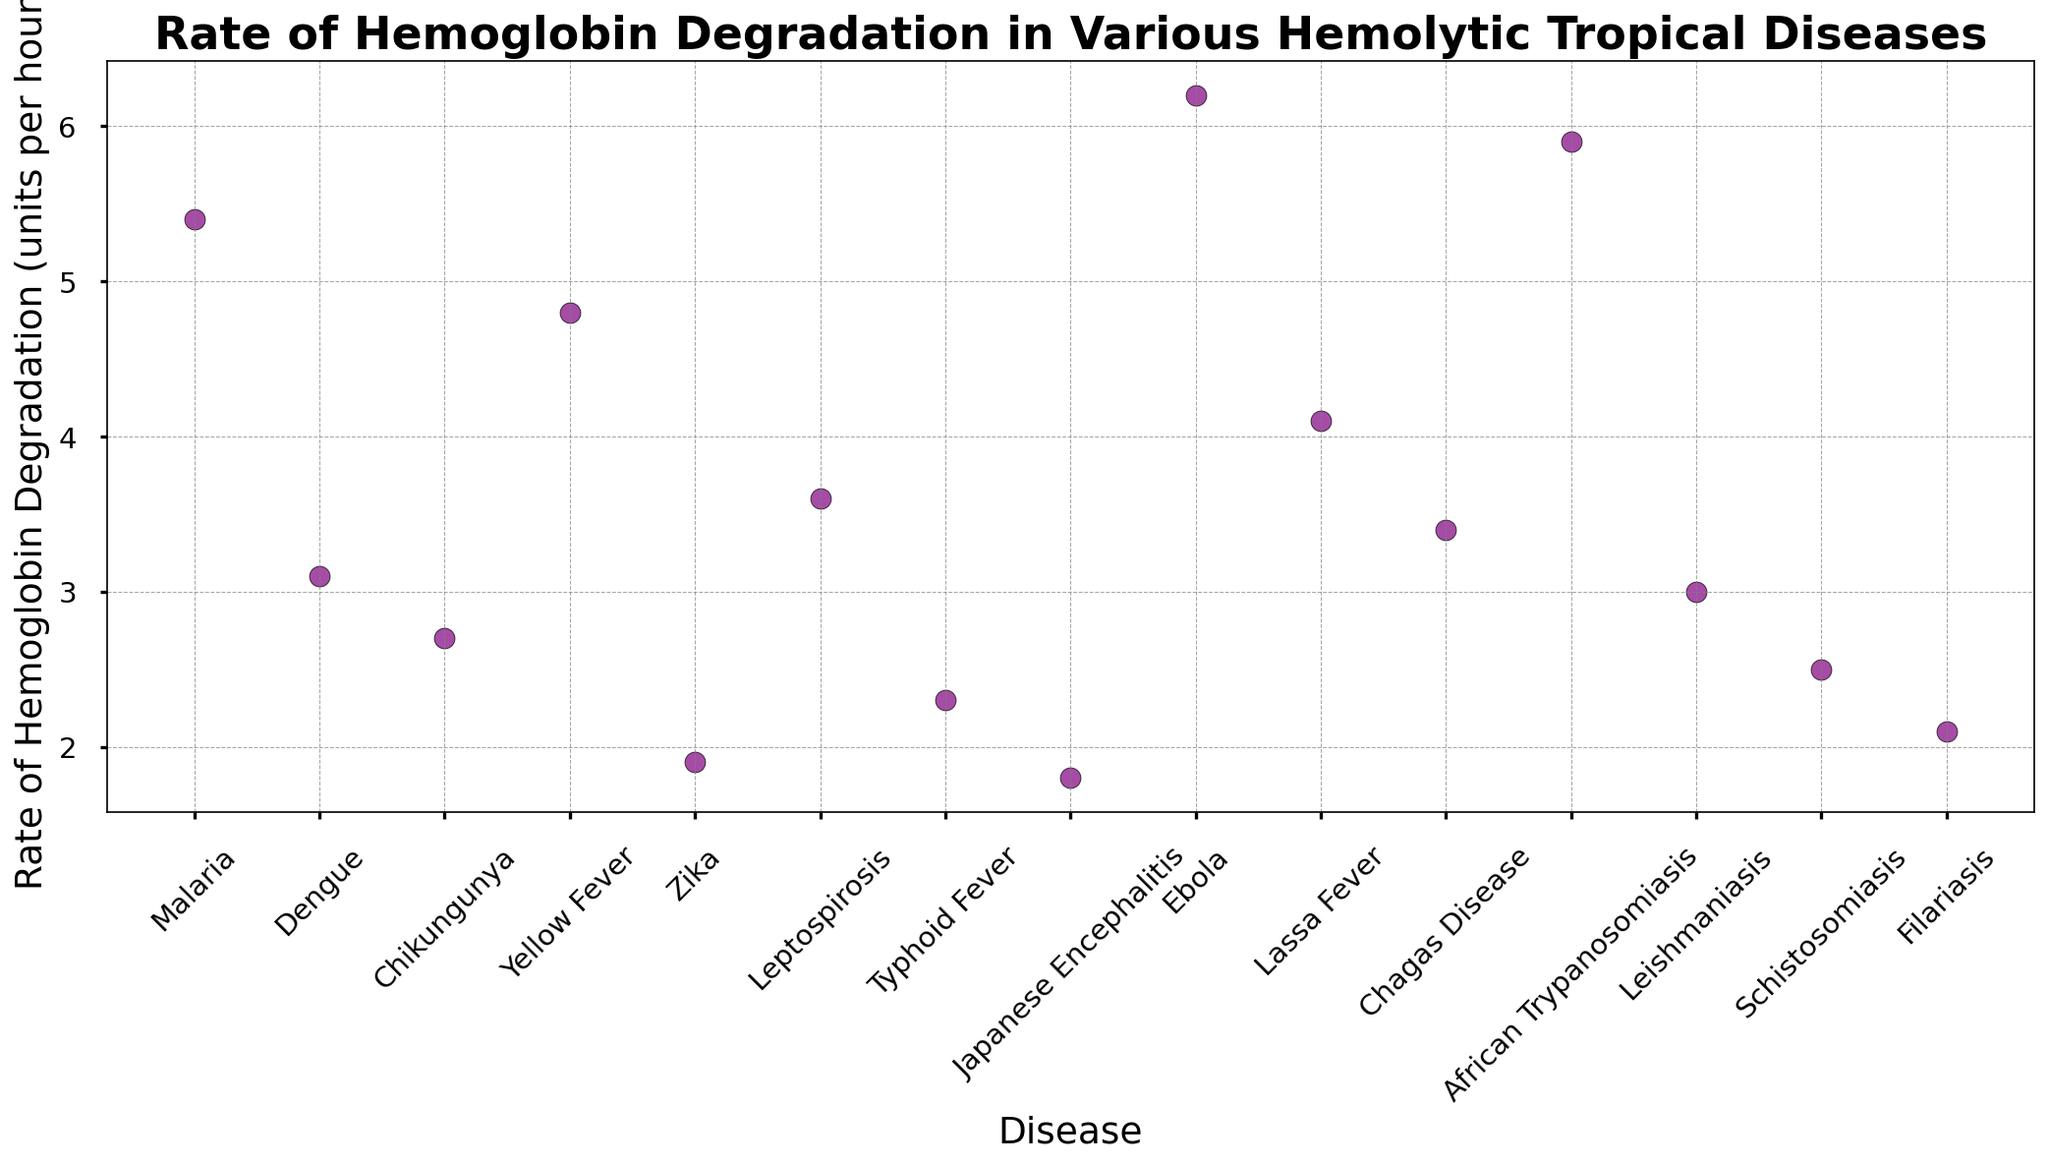Which disease has the highest rate of hemoglobin degradation? Look at the highest point in the scatter plot. The disease with the highest rate of hemoglobin degradation is Ebola at 6.2 units per hour.
Answer: Ebola What is the rate of hemoglobin degradation for Malaria? Identify the point corresponding to Malaria on the x-axis and check its y-value. The rate for Malaria is 5.4 units per hour.
Answer: 5.4 units per hour Which diseases have a rate of hemoglobin degradation higher than 4.5 units per hour? Locate all points with y-values greater than 4.5 units per hour. The diseases are Malaria, Yellow Fever, Ebola, and African Trypanosomiasis.
Answer: Malaria, Yellow Fever, Ebola, African Trypanosomiasis What is the difference in the rate of hemoglobin degradation between Ebola and Zika? Subtract the rate for Zika from the rate for Ebola: 6.2 units per hour (Ebola) - 1.9 units per hour (Zika) = 4.3 units per hour.
Answer: 4.3 units per hour What is the average rate of hemoglobin degradation for Dengue, Yellow Fever, and Leishmaniasis? Sum the rates for Dengue (3.1), Yellow Fever (4.8), and Leishmaniasis (3.0) and divide by 3: (3.1 + 4.8 + 3.0) / 3 = 3.63 units per hour.
Answer: 3.63 units per hour Rank the diseases by the rate of hemoglobin degradation from lowest to highest. Order the y-values from the scatter plot in ascending order: Japanese Encephalitis (1.8), Zika (1.9), Filariasis (2.1), Typhoid Fever (2.3), Schistosomiasis (2.5), Chikungunya (2.7), Leishmaniasis (3.0), Dengue (3.1), Chagas Disease (3.4), Leptospirosis (3.6), Lassa Fever (4.1), Yellow Fever (4.8), Malaria (5.4), African Trypanosomiasis (5.9), Ebola (6.2).
Answer: Japanese Encephalitis, Zika, Filariasis, Typhoid Fever, Schistosomiasis, Chikungunya, Leishmaniasis, Dengue, Chagas Disease, Leptospirosis, Lassa Fever, Yellow Fever, Malaria, African Trypanosomiasis, Ebola How many diseases have a rate of hemoglobin degradation below 3 units per hour? Count the points with y-values less than 3 units per hour: Japanese Encephalitis, Zika, Filariasis, Typhoid Fever, Schistosomiasis, Chikungunya, and Leishmaniasis. There are 7 diseases in total.
Answer: 7 What is the combined rate of hemoglobin degradation for Chagas Disease and Lassa Fever? Add the rates for Chagas Disease (3.4) and Lassa Fever (4.1): 3.4 + 4.1 = 7.5 units per hour.
Answer: 7.5 units per hour 